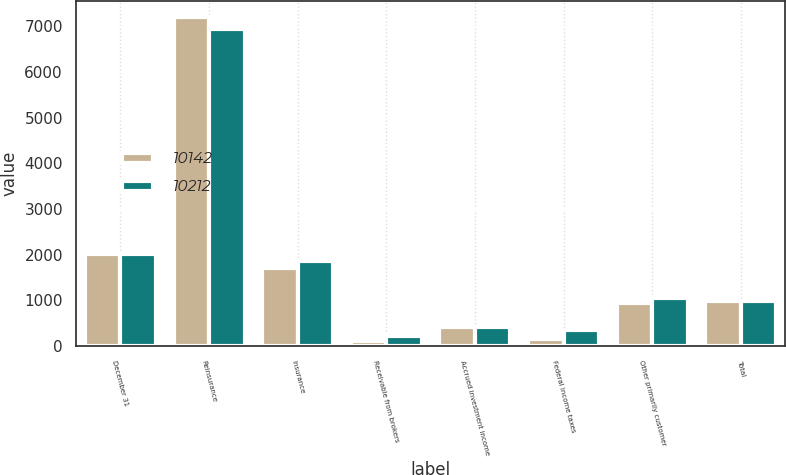Convert chart. <chart><loc_0><loc_0><loc_500><loc_500><stacked_bar_chart><ecel><fcel>December 31<fcel>Reinsurance<fcel>Insurance<fcel>Receivable from brokers<fcel>Accrued investment income<fcel>Federal income taxes<fcel>Other primarily customer<fcel>Total<nl><fcel>10142<fcel>2010<fcel>7204<fcel>1717<fcel>103<fcel>426<fcel>150<fcel>946<fcel>996<nl><fcel>10212<fcel>2009<fcel>6932<fcel>1858<fcel>221<fcel>417<fcel>352<fcel>1046<fcel>996<nl></chart> 